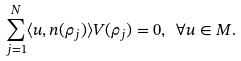Convert formula to latex. <formula><loc_0><loc_0><loc_500><loc_500>\sum _ { j = 1 } ^ { N } \langle u , n ( \rho _ { j } ) \rangle V ( \rho _ { j } ) = 0 , \ \forall u \in M .</formula> 